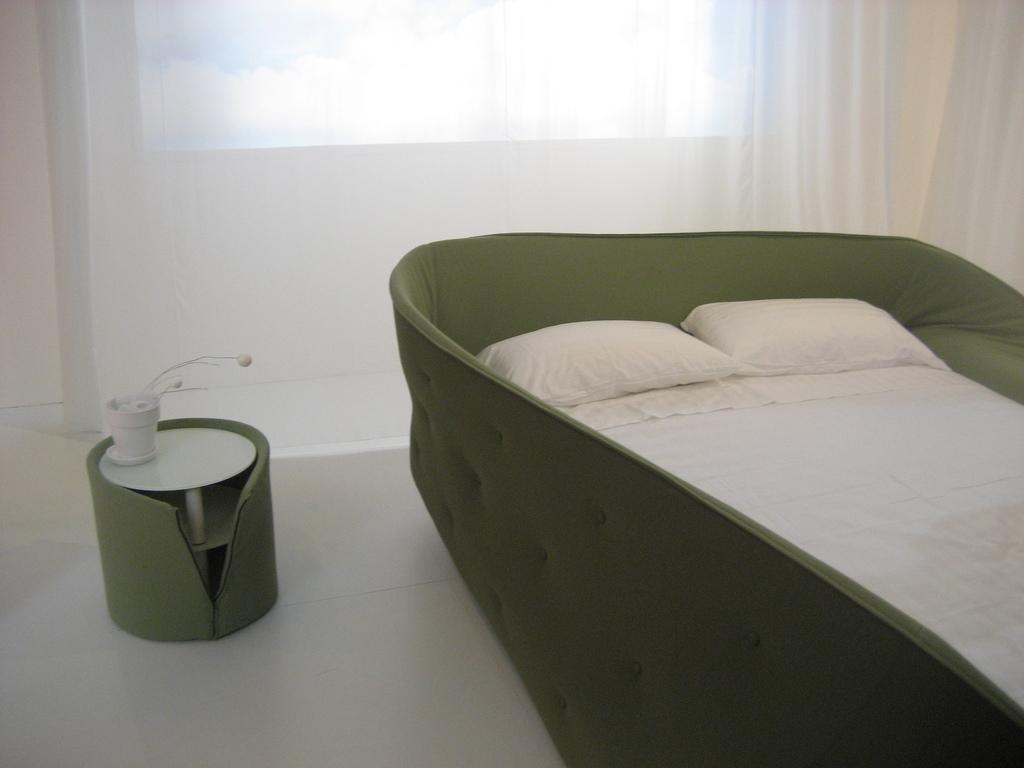In one or two sentences, can you explain what this image depicts? This image is taken indoors. In the background there is a wall with a window and there is a curtain which is white in color. At the bottom of the image there is a floor. On the right side of the image there is a bed with a bed sheet and two pillows. On the left side of the image there is a table with a flower vase on it. 